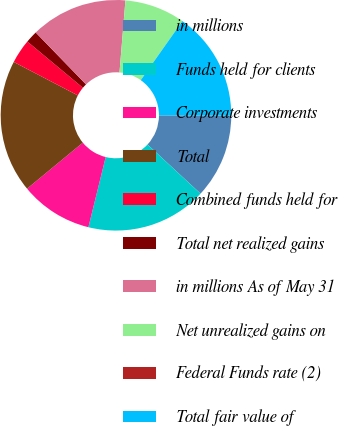Convert chart. <chart><loc_0><loc_0><loc_500><loc_500><pie_chart><fcel>in millions<fcel>Funds held for clients<fcel>Corporate investments<fcel>Total<fcel>Combined funds held for<fcel>Total net realized gains<fcel>in millions As of May 31<fcel>Net unrealized gains on<fcel>Federal Funds rate (2)<fcel>Total fair value of<nl><fcel>11.86%<fcel>16.95%<fcel>10.17%<fcel>18.64%<fcel>3.39%<fcel>1.7%<fcel>13.56%<fcel>8.47%<fcel>0.0%<fcel>15.25%<nl></chart> 